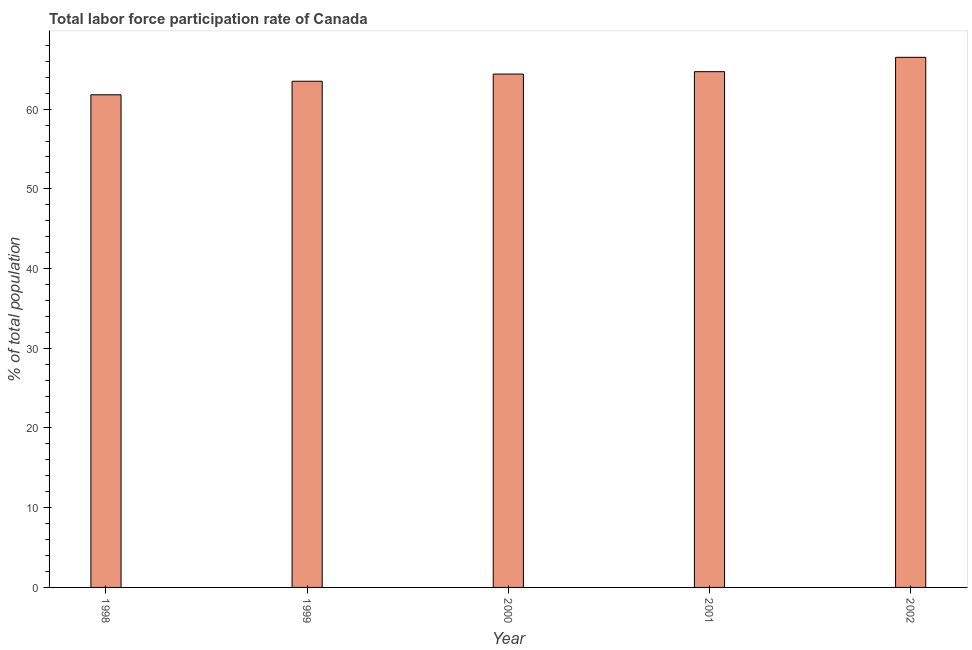Does the graph contain any zero values?
Make the answer very short. No. What is the title of the graph?
Your answer should be compact. Total labor force participation rate of Canada. What is the label or title of the X-axis?
Make the answer very short. Year. What is the label or title of the Y-axis?
Provide a succinct answer. % of total population. What is the total labor force participation rate in 2001?
Your answer should be very brief. 64.7. Across all years, what is the maximum total labor force participation rate?
Provide a succinct answer. 66.5. Across all years, what is the minimum total labor force participation rate?
Give a very brief answer. 61.8. In which year was the total labor force participation rate minimum?
Give a very brief answer. 1998. What is the sum of the total labor force participation rate?
Keep it short and to the point. 320.9. What is the difference between the total labor force participation rate in 1998 and 2002?
Your answer should be compact. -4.7. What is the average total labor force participation rate per year?
Give a very brief answer. 64.18. What is the median total labor force participation rate?
Provide a short and direct response. 64.4. Do a majority of the years between 2002 and 2000 (inclusive) have total labor force participation rate greater than 12 %?
Your answer should be very brief. Yes. Is the difference between the total labor force participation rate in 1999 and 2002 greater than the difference between any two years?
Offer a very short reply. No. Is the sum of the total labor force participation rate in 2000 and 2002 greater than the maximum total labor force participation rate across all years?
Keep it short and to the point. Yes. What is the difference between the highest and the lowest total labor force participation rate?
Give a very brief answer. 4.7. How many years are there in the graph?
Provide a short and direct response. 5. Are the values on the major ticks of Y-axis written in scientific E-notation?
Offer a terse response. No. What is the % of total population in 1998?
Keep it short and to the point. 61.8. What is the % of total population of 1999?
Make the answer very short. 63.5. What is the % of total population of 2000?
Provide a short and direct response. 64.4. What is the % of total population of 2001?
Keep it short and to the point. 64.7. What is the % of total population in 2002?
Keep it short and to the point. 66.5. What is the difference between the % of total population in 1998 and 2000?
Make the answer very short. -2.6. What is the difference between the % of total population in 1998 and 2002?
Provide a short and direct response. -4.7. What is the difference between the % of total population in 1999 and 2000?
Keep it short and to the point. -0.9. What is the difference between the % of total population in 1999 and 2001?
Your response must be concise. -1.2. What is the difference between the % of total population in 2000 and 2001?
Offer a very short reply. -0.3. What is the ratio of the % of total population in 1998 to that in 2000?
Your answer should be compact. 0.96. What is the ratio of the % of total population in 1998 to that in 2001?
Your answer should be compact. 0.95. What is the ratio of the % of total population in 1998 to that in 2002?
Give a very brief answer. 0.93. What is the ratio of the % of total population in 1999 to that in 2000?
Offer a very short reply. 0.99. What is the ratio of the % of total population in 1999 to that in 2002?
Provide a succinct answer. 0.95. 